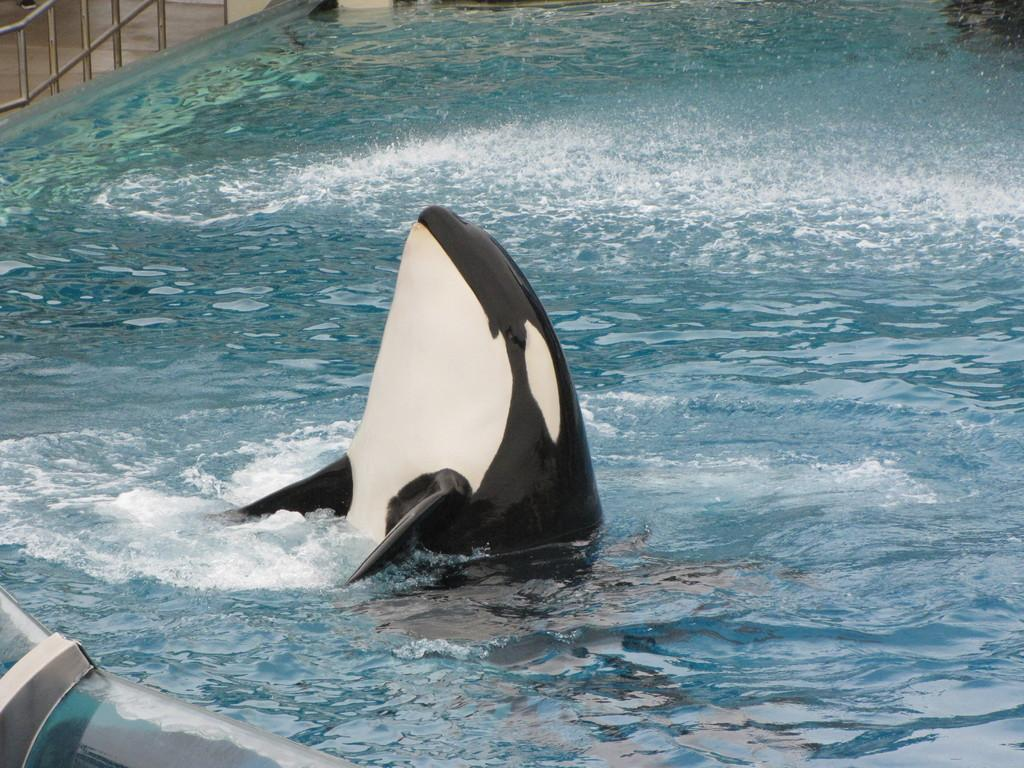What animal is the main subject of the image? There is a shark in the image. What color combination is used for the shark? The shark is in black and white color combination. Where is the shark located in the image? The shark is in the water. What can be seen in the background of the image? There is a fence in the background of the image. What is the price of the ice cream cone being held by the shark in the image? There is no ice cream cone or any reference to a price in the image; it features a shark in black and white color combination in the water. 